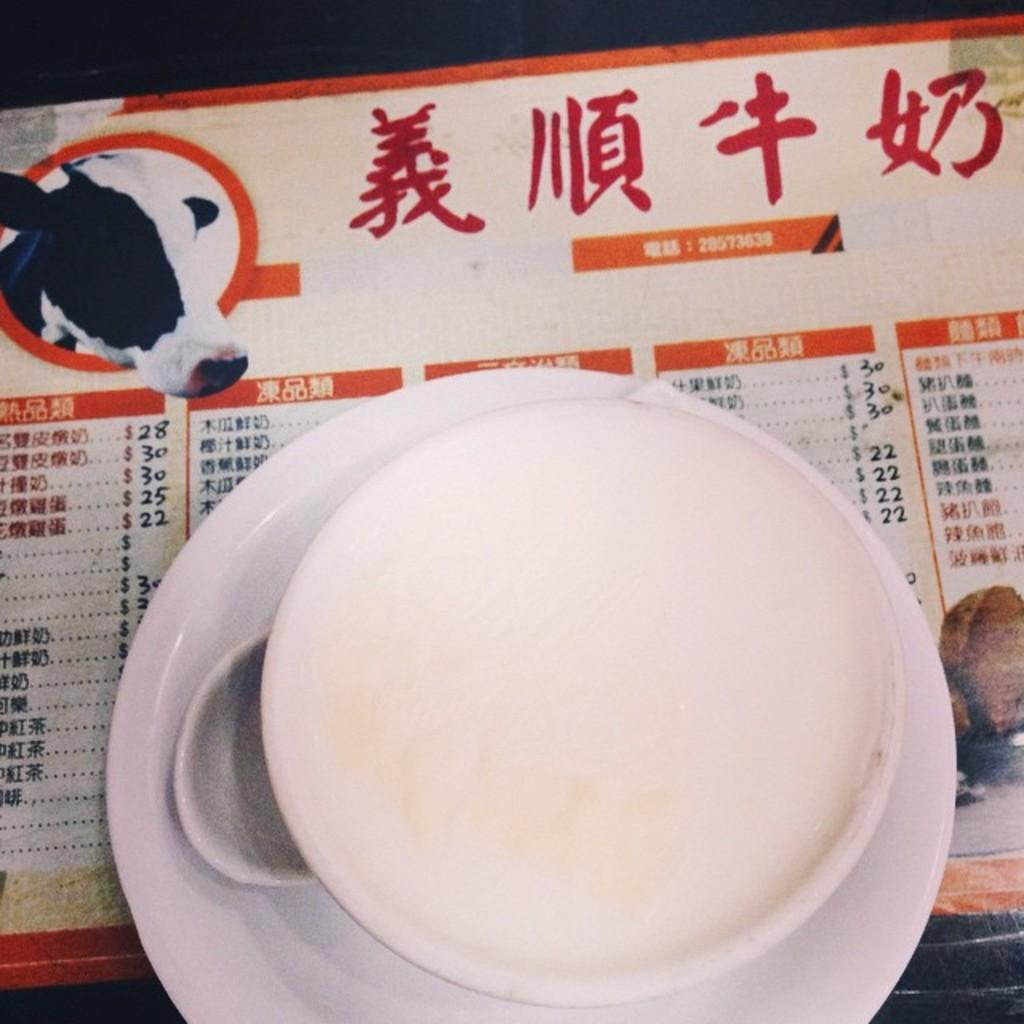What is the main structure in the center of the image? There is a platform in the center of the image. What is placed on the platform? There is a plate and a paper with text and images on the platform. Are there any other objects on the platform? Yes, there are other objects on the platform. What theory is being attacked by the birds in the image? There are no birds present in the image, and therefore no theory is being attacked. 